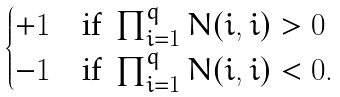Convert formula to latex. <formula><loc_0><loc_0><loc_500><loc_500>\begin{cases} + 1 \quad \text {if } \prod _ { i = 1 } ^ { q } N ( i , i ) > 0 \\ - 1 \quad \text {if } \prod _ { i = 1 } ^ { q } N ( i , i ) < 0 . \end{cases}</formula> 